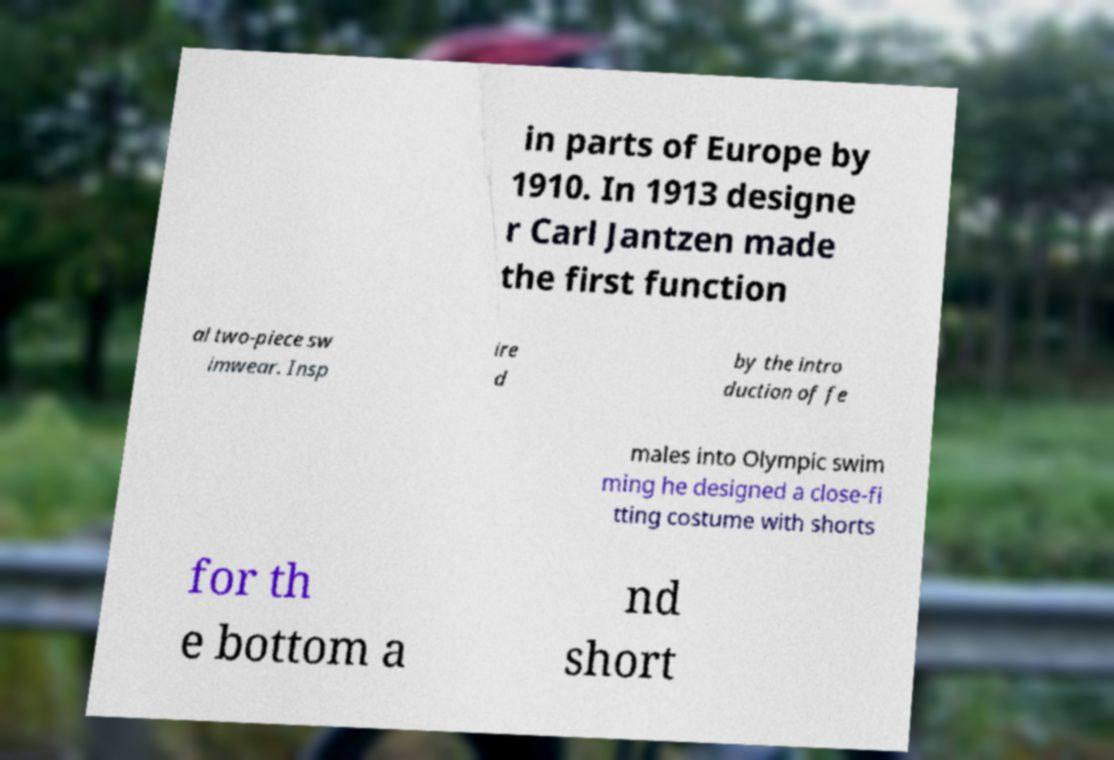Please identify and transcribe the text found in this image. in parts of Europe by 1910. In 1913 designe r Carl Jantzen made the first function al two-piece sw imwear. Insp ire d by the intro duction of fe males into Olympic swim ming he designed a close-fi tting costume with shorts for th e bottom a nd short 